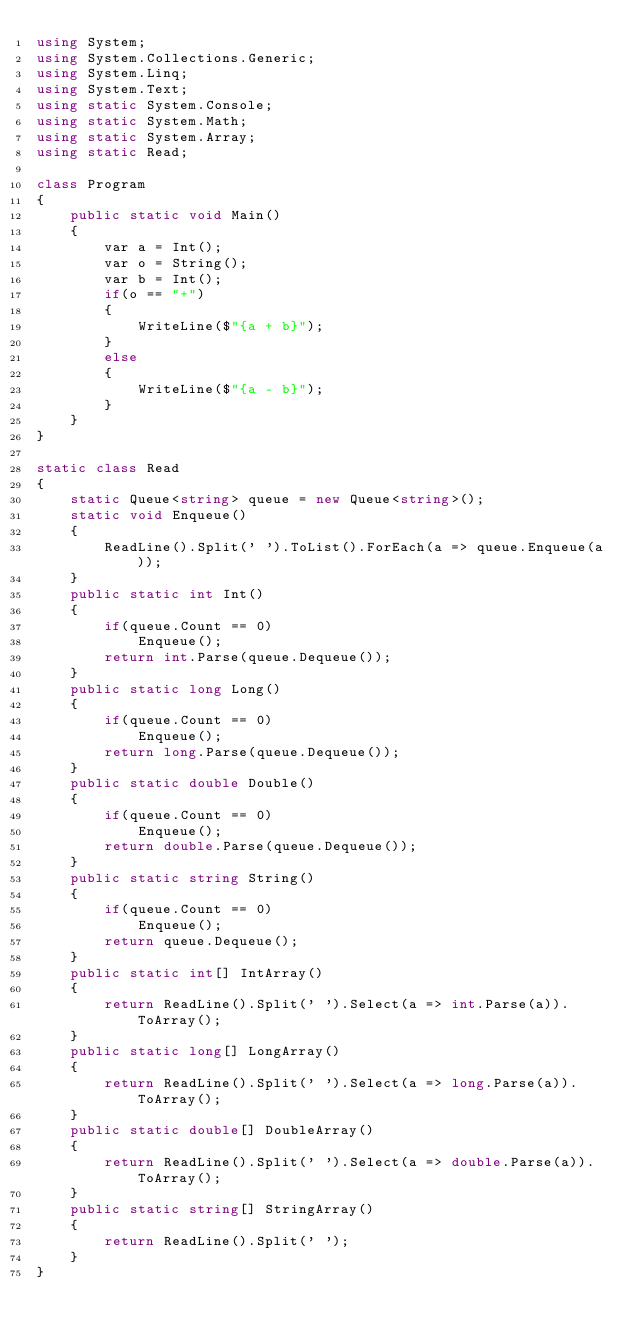Convert code to text. <code><loc_0><loc_0><loc_500><loc_500><_C#_>using System;
using System.Collections.Generic;
using System.Linq;
using System.Text;
using static System.Console;
using static System.Math;
using static System.Array;
using static Read;

class Program
{
    public static void Main()
    {
        var a = Int();
        var o = String();
        var b = Int();
        if(o == "+")
        {
            WriteLine($"{a + b}");
        }
        else
        {
            WriteLine($"{a - b}");
        }
    }
}

static class Read
{
    static Queue<string> queue = new Queue<string>();
    static void Enqueue()
    {
        ReadLine().Split(' ').ToList().ForEach(a => queue.Enqueue(a));
    }
    public static int Int()
    {
        if(queue.Count == 0)
            Enqueue();
        return int.Parse(queue.Dequeue());
    }
    public static long Long()
    {
        if(queue.Count == 0)
            Enqueue();
        return long.Parse(queue.Dequeue());
    }
    public static double Double()
    {
        if(queue.Count == 0)
            Enqueue();
        return double.Parse(queue.Dequeue());
    }
    public static string String()
    {
        if(queue.Count == 0)
            Enqueue();
        return queue.Dequeue();
    }
    public static int[] IntArray()
    {
        return ReadLine().Split(' ').Select(a => int.Parse(a)).ToArray();
    }
    public static long[] LongArray()
    {
        return ReadLine().Split(' ').Select(a => long.Parse(a)).ToArray();
    }
    public static double[] DoubleArray()
    {
        return ReadLine().Split(' ').Select(a => double.Parse(a)).ToArray();
    }
    public static string[] StringArray()
    {
        return ReadLine().Split(' ');
    }
}
</code> 